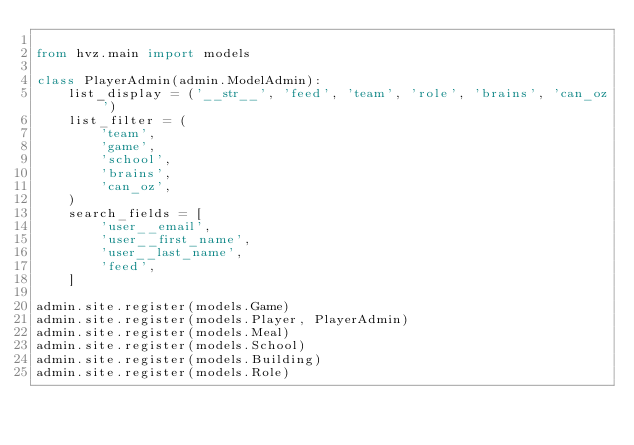Convert code to text. <code><loc_0><loc_0><loc_500><loc_500><_Python_>
from hvz.main import models

class PlayerAdmin(admin.ModelAdmin):
    list_display = ('__str__', 'feed', 'team', 'role', 'brains', 'can_oz')
    list_filter = (
        'team',
        'game',
        'school',
        'brains',
        'can_oz',
    )
    search_fields = [
        'user__email',
        'user__first_name',
        'user__last_name',
        'feed',
    ]

admin.site.register(models.Game)
admin.site.register(models.Player, PlayerAdmin)
admin.site.register(models.Meal)
admin.site.register(models.School)
admin.site.register(models.Building)
admin.site.register(models.Role)
</code> 